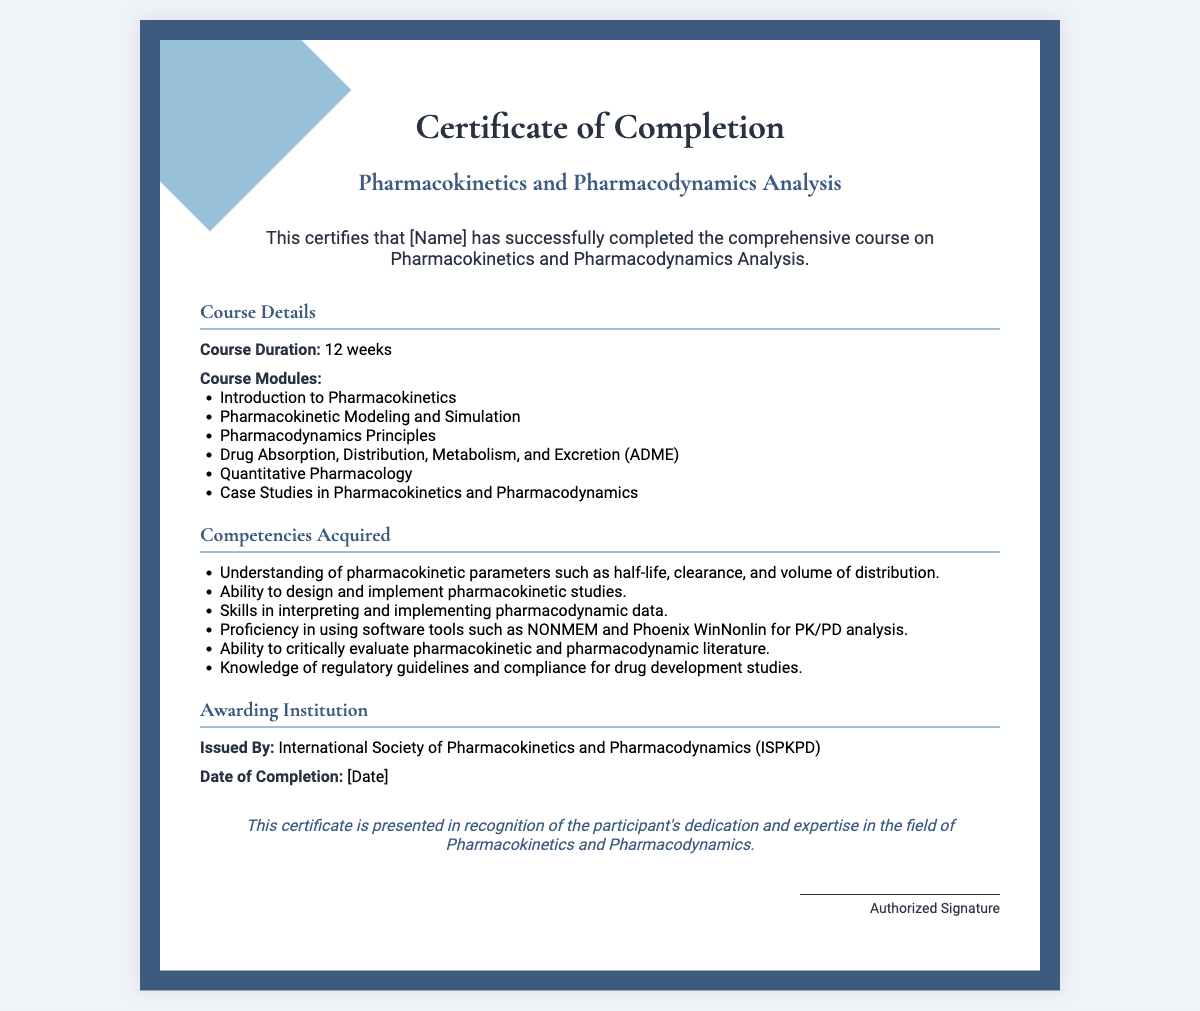What is the title of the course? The title of the course is specifically stated in the document as "Pharmacokinetics and Pharmacodynamics Analysis."
Answer: Pharmacokinetics and Pharmacodynamics Analysis Who issued the certificate? The document states that the certificate is issued by the "International Society of Pharmacokinetics and Pharmacodynamics (ISPKPD)."
Answer: International Society of Pharmacokinetics and Pharmacodynamics (ISPKPD) What is the course duration? The duration of the course is outlined in the document as "12 weeks."
Answer: 12 weeks What date is the certificate dated? The document specifies a placeholder for the date, indicated as "[Date]."
Answer: [Date] Name one software tool for PK/PD analysis mentioned. The competencies section lists several tools; one specific tool mentioned is "NONMEM."
Answer: NONMEM How many course modules are there? The document lists six specific modules under the Course Modules section, indicating the quantity clearly.
Answer: 6 What is one competency acquired through the course? The competencies section lists multiple competencies; one example is "Understanding of pharmacokinetic parameters."
Answer: Understanding of pharmacokinetic parameters What does the footer of the certificate represent? The footer summarizes the purpose of the certificate, indicating it recognizes dedication and expertise.
Answer: Recognition of dedication and expertise Who is responsible for the authorized signature? The document indicates that the certificate will be signed by an "Authorized Signature," but does not provide a specific name.
Answer: Authorized Signature 